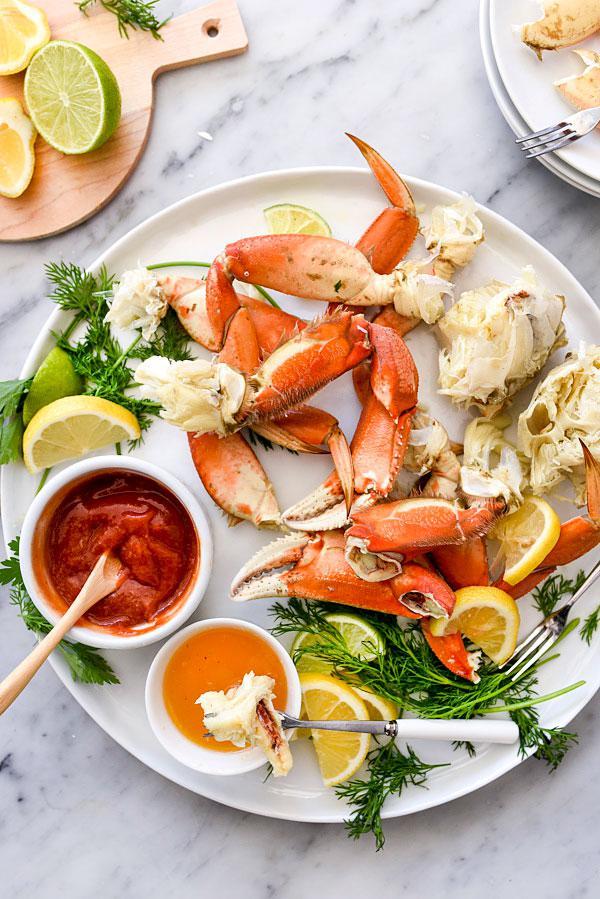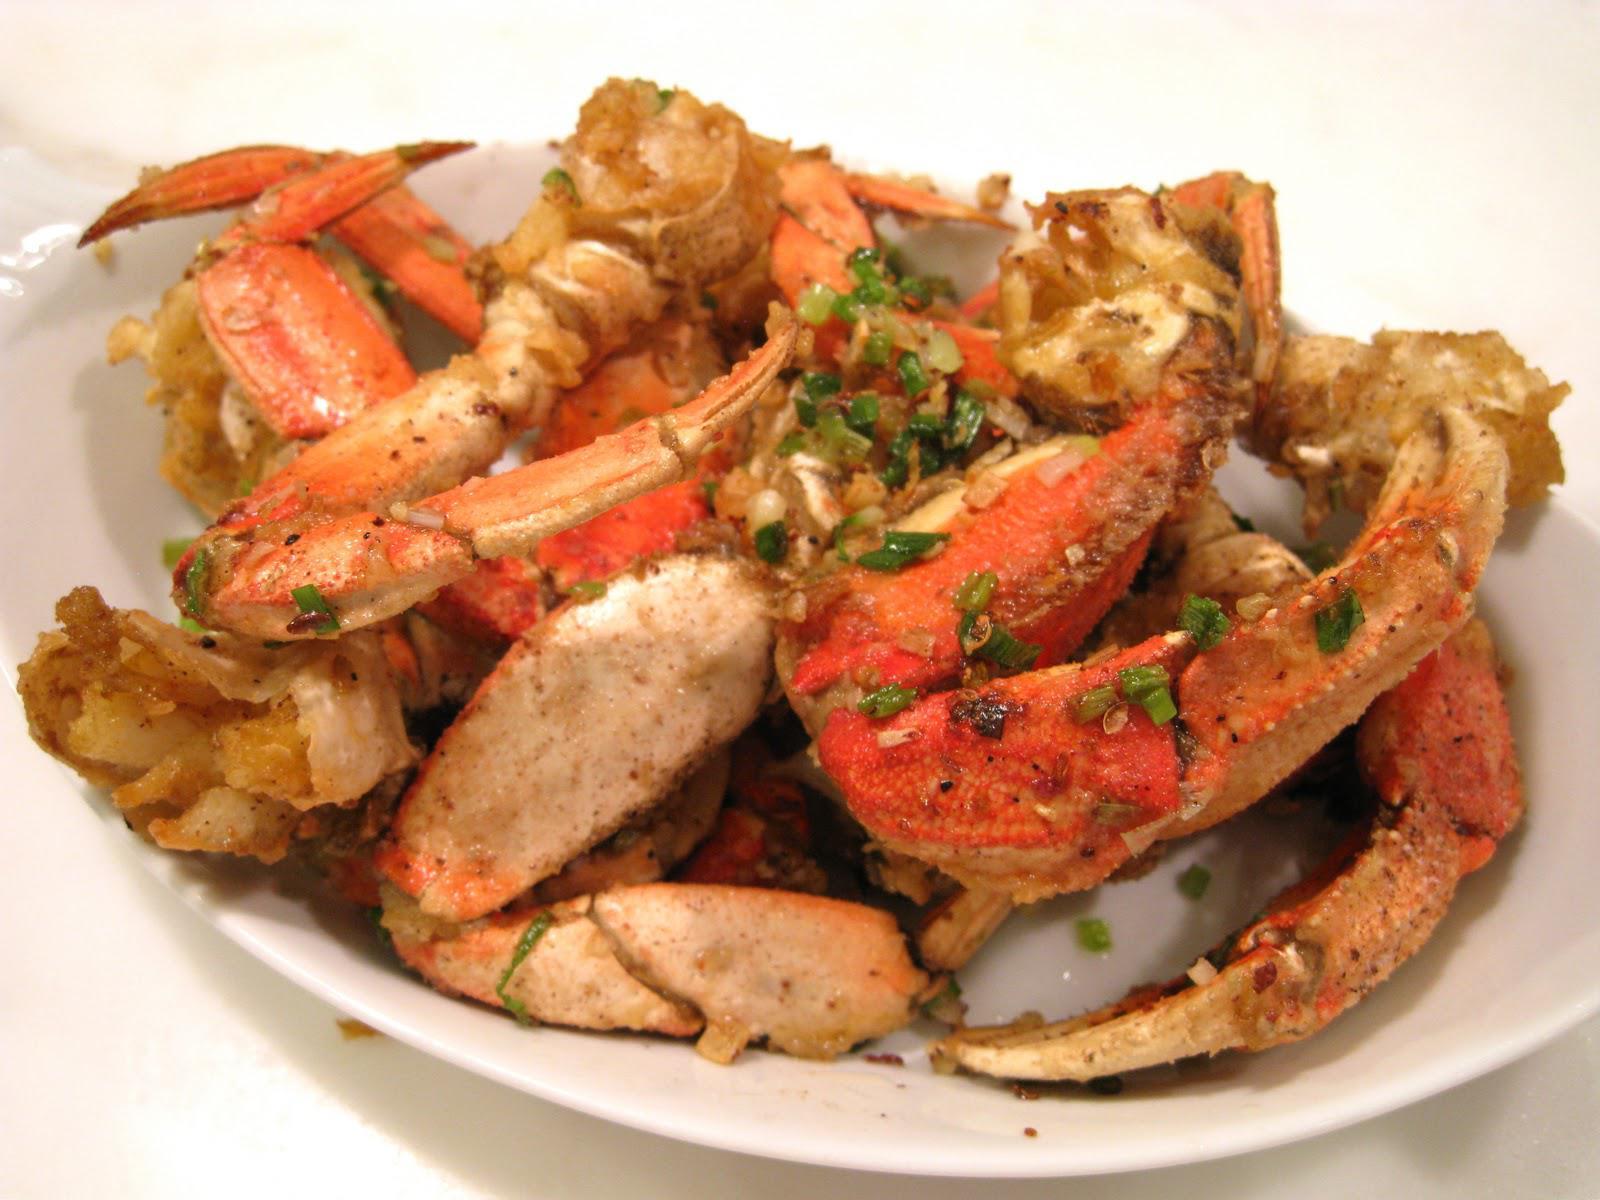The first image is the image on the left, the second image is the image on the right. Analyze the images presented: Is the assertion "There is sauce next to the crab meat." valid? Answer yes or no. Yes. 